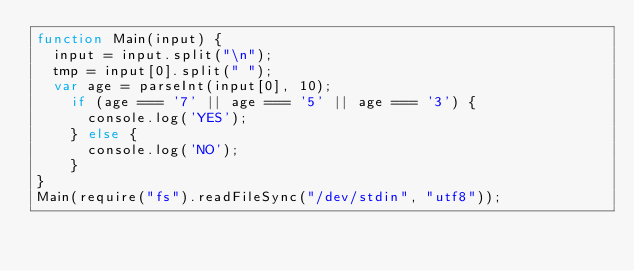<code> <loc_0><loc_0><loc_500><loc_500><_JavaScript_>function Main(input) {
	input = input.split("\n");
	tmp = input[0].split(" ");
	var age = parseInt(input[0], 10);
    if (age === '7' || age === '5' || age === '3') {
      console.log('YES');
    } else {
      console.log('NO');
    }
}
Main(require("fs").readFileSync("/dev/stdin", "utf8"));</code> 